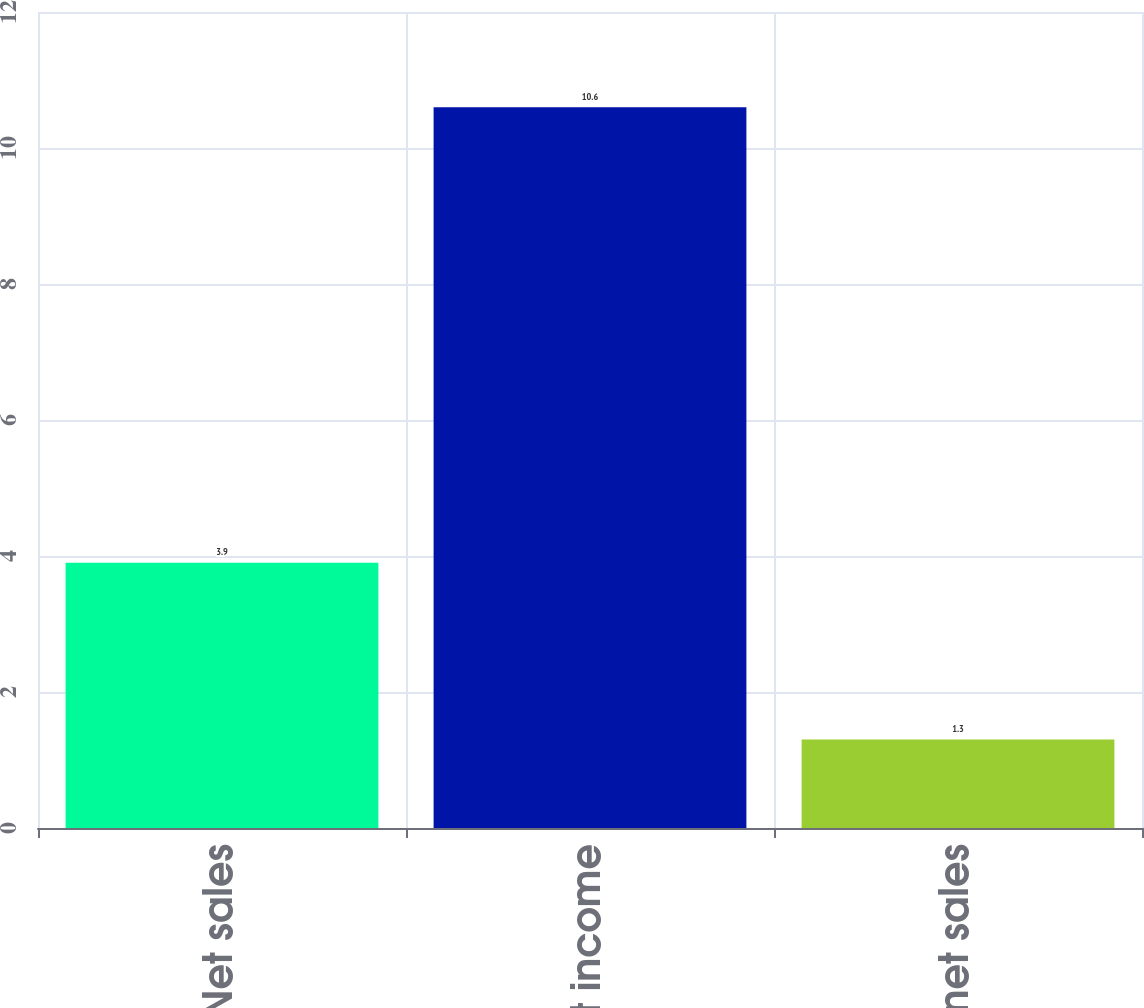<chart> <loc_0><loc_0><loc_500><loc_500><bar_chart><fcel>Net sales<fcel>Segment income<fcel>of net sales<nl><fcel>3.9<fcel>10.6<fcel>1.3<nl></chart> 